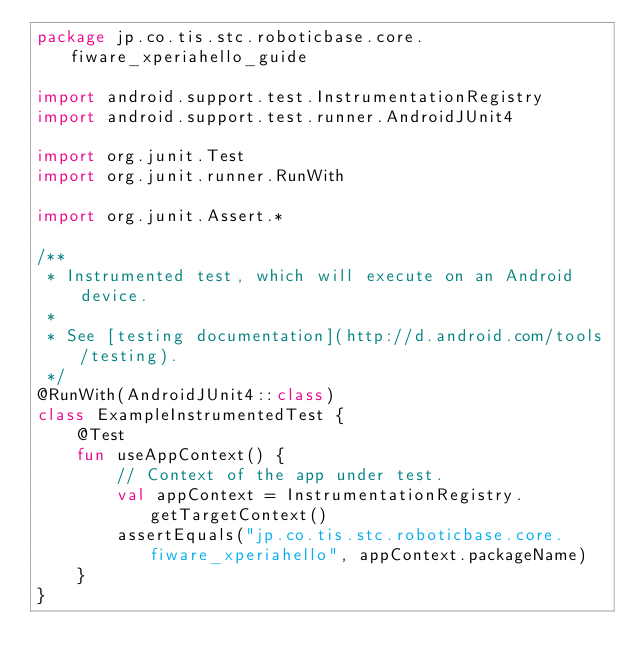Convert code to text. <code><loc_0><loc_0><loc_500><loc_500><_Kotlin_>package jp.co.tis.stc.roboticbase.core.fiware_xperiahello_guide

import android.support.test.InstrumentationRegistry
import android.support.test.runner.AndroidJUnit4

import org.junit.Test
import org.junit.runner.RunWith

import org.junit.Assert.*

/**
 * Instrumented test, which will execute on an Android device.
 *
 * See [testing documentation](http://d.android.com/tools/testing).
 */
@RunWith(AndroidJUnit4::class)
class ExampleInstrumentedTest {
    @Test
    fun useAppContext() {
        // Context of the app under test.
        val appContext = InstrumentationRegistry.getTargetContext()
        assertEquals("jp.co.tis.stc.roboticbase.core.fiware_xperiahello", appContext.packageName)
    }
}
</code> 